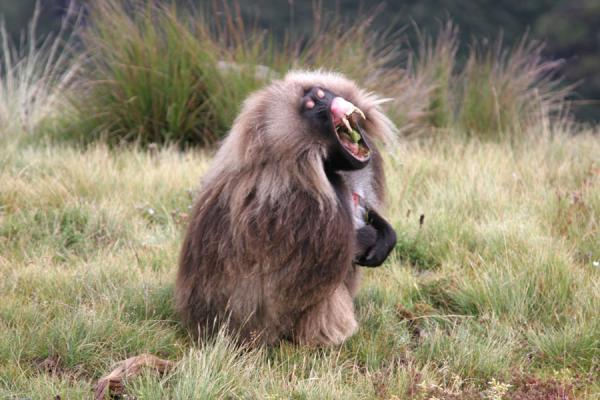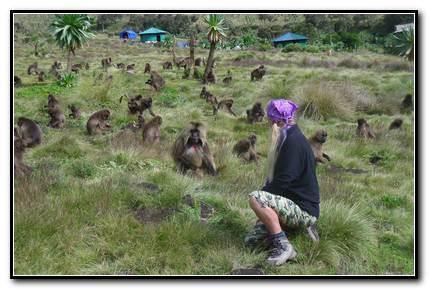The first image is the image on the left, the second image is the image on the right. Examine the images to the left and right. Is the description "The left image contains exactly one baboon." accurate? Answer yes or no. Yes. The first image is the image on the left, the second image is the image on the right. Examine the images to the left and right. Is the description "The right image shows monkeys crouching on the grass and reaching toward the ground, with no human in the foreground." accurate? Answer yes or no. No. 